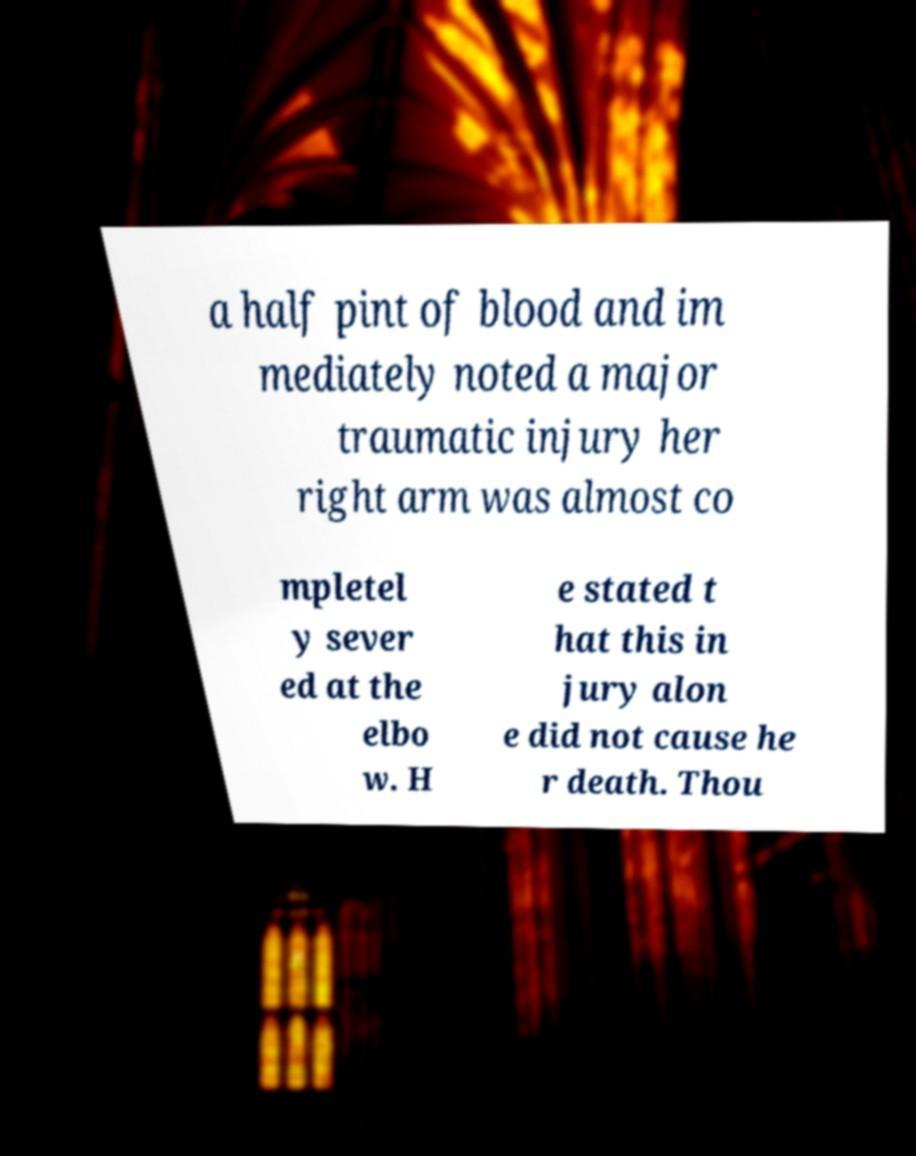For documentation purposes, I need the text within this image transcribed. Could you provide that? a half pint of blood and im mediately noted a major traumatic injury her right arm was almost co mpletel y sever ed at the elbo w. H e stated t hat this in jury alon e did not cause he r death. Thou 